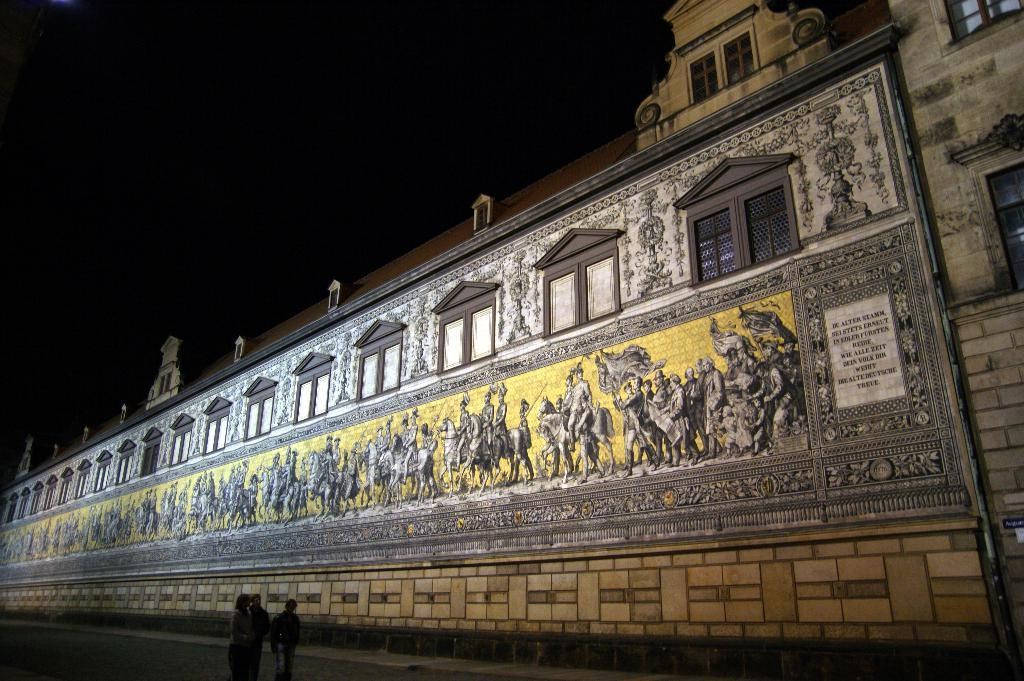Who or what can be seen in the image? There are people in the image. What decorative elements are present on the walls? There are paintings on the wall. What architectural feature allows natural light to enter the room? There are windows in the image. How many birds are flying through the room in the image? There are no birds visible in the image. 